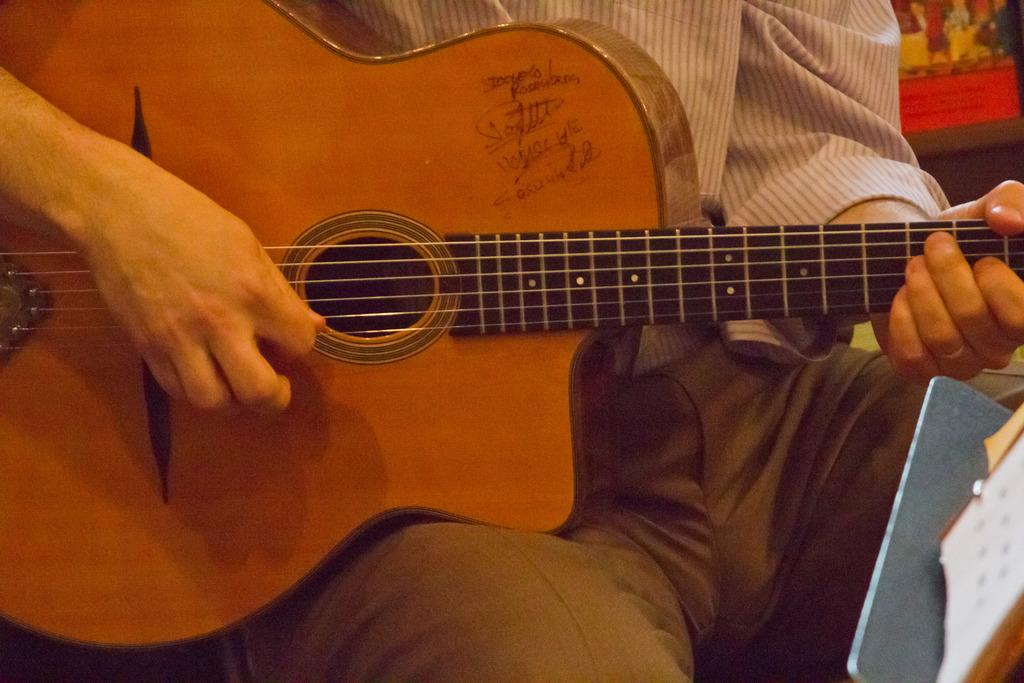What type of setting is depicted in the image? The image is of an indoor setting. Who is present in the image? There is a man in the image. What is the man wearing? The man is wearing a white shirt. What is the man doing in the image? The man is sitting and playing a guitar. What can be seen on the left side of the image? There is a stand on the left side of the image. How many bricks are visible in the image? There are no bricks present in the image. What is the manager's role in the image? There is no manager present in the image. 